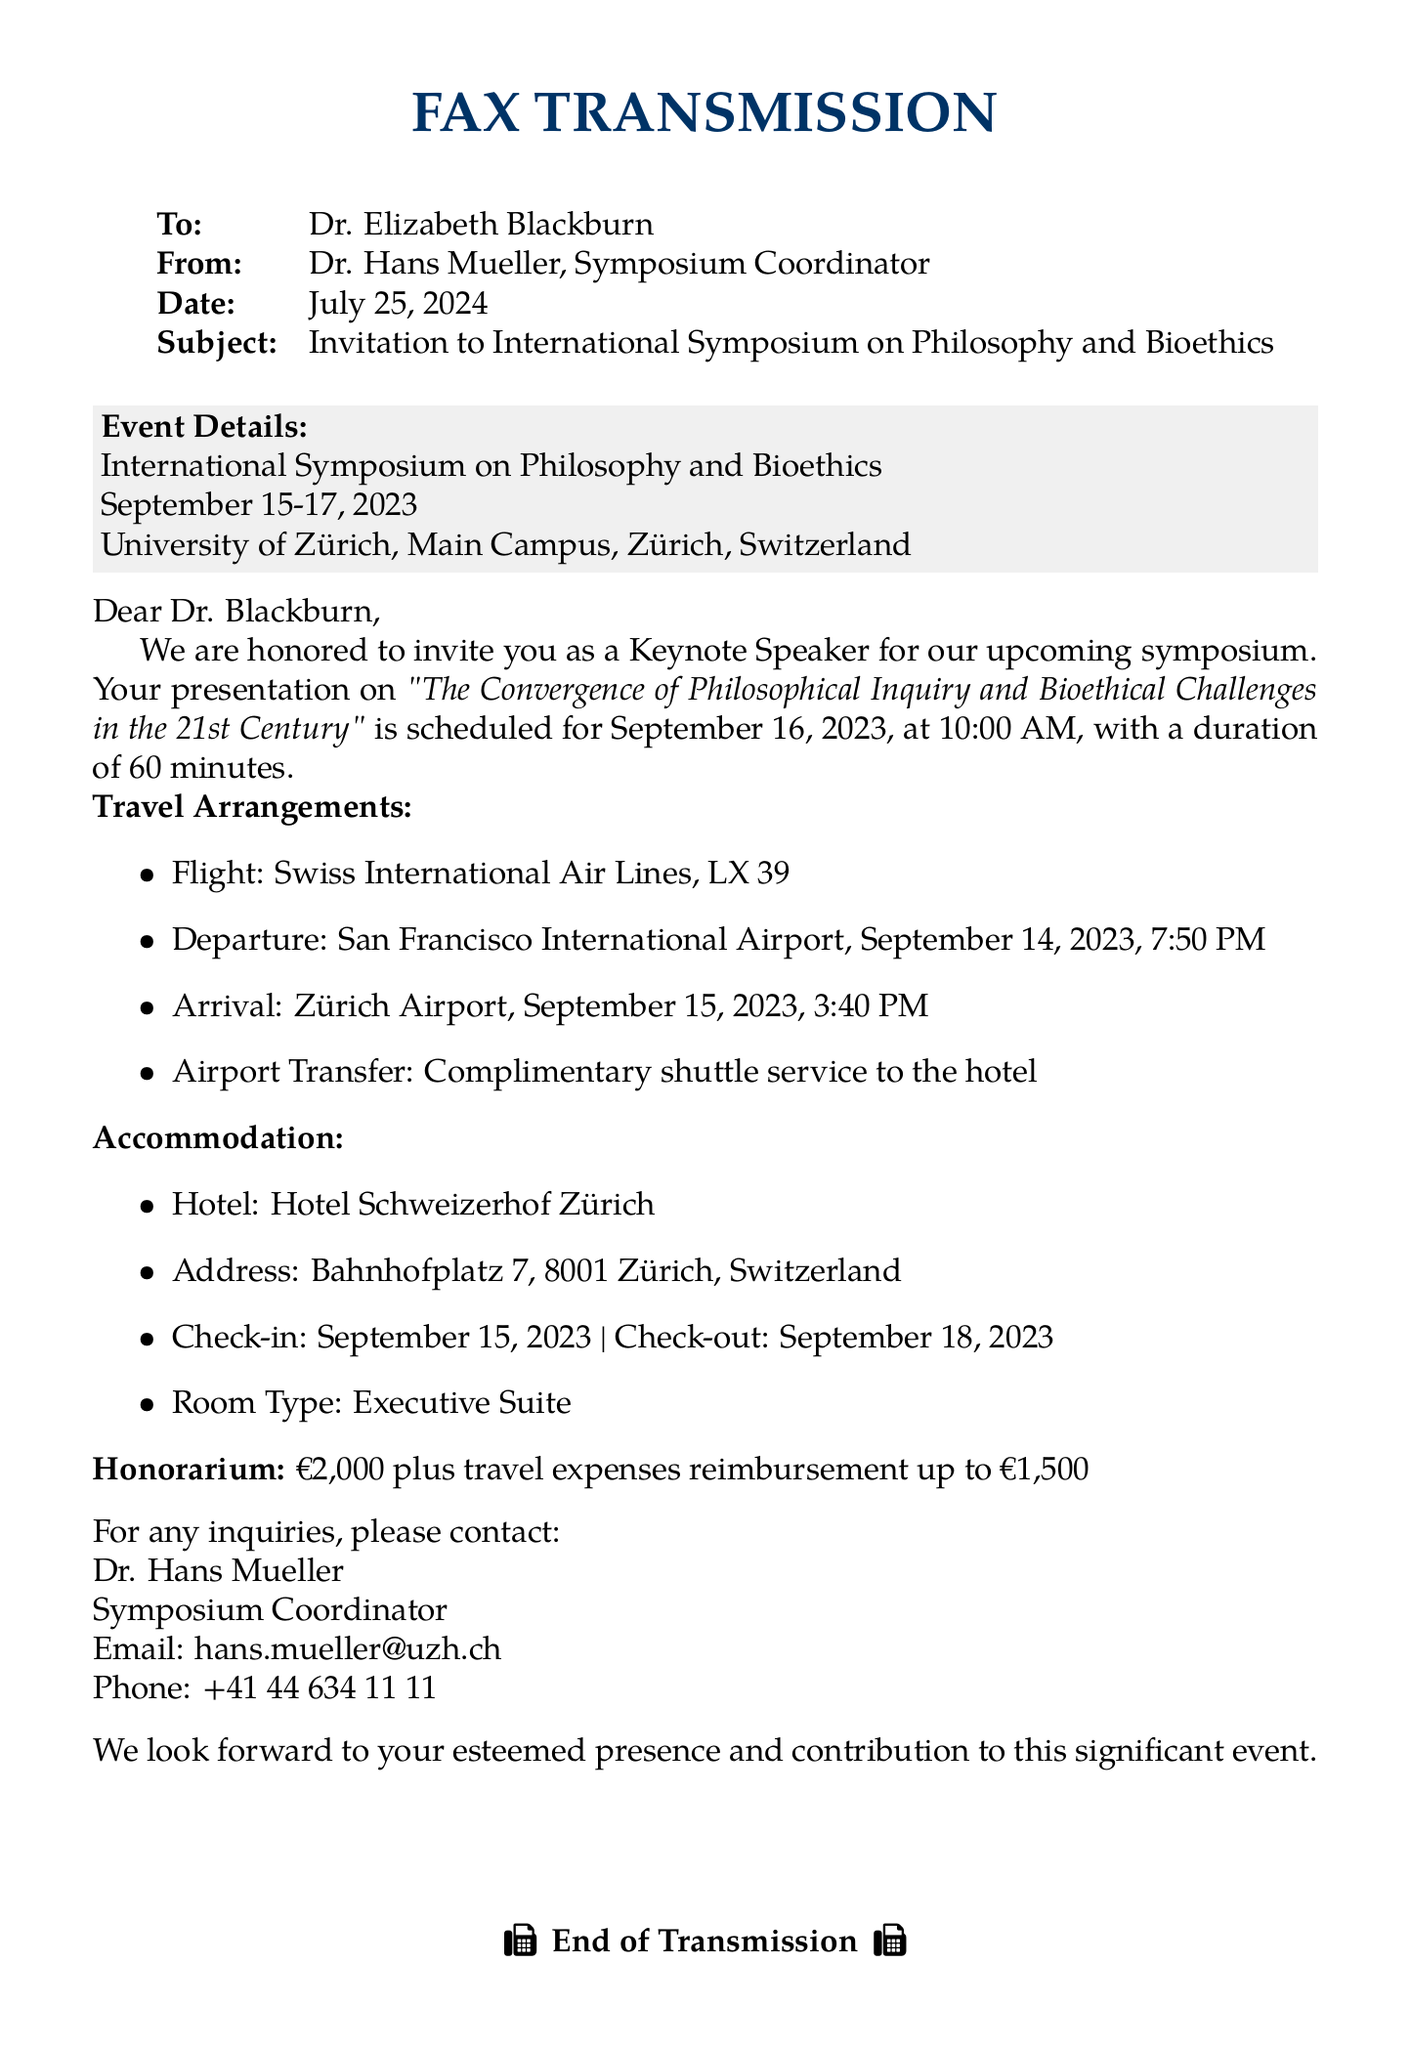What are the dates of the symposium? The symposium is scheduled for September 15-17, 2023, as mentioned in the event details.
Answer: September 15-17, 2023 Who is the keynote speaker? The document addresses Dr. Elizabeth Blackburn, indicating she is the intended keynote speaker.
Answer: Dr. Elizabeth Blackburn What is the honorarium amount? The document states the honorarium is €2,000.
Answer: €2,000 What is the check-in date for the hotel? The accommodation section specifies the check-in date as September 15, 2023.
Answer: September 15, 2023 What flight number is scheduled for the keynote speaker? The travel arrangements section lists flight LX 39 as the scheduled flight.
Answer: LX 39 Which hotel will accommodate the keynote speaker? The document specifies the Hotel Schweizerhof Zürich as the accommodation.
Answer: Hotel Schweizerhof Zürich At what time is the keynote presentation scheduled? The document details that the presentation is scheduled for 10:00 AM on September 16, 2023.
Answer: 10:00 AM What is the airport for the arrival? The travel arrangements section indicates Zürich Airport as the arrival airport.
Answer: Zürich Airport What is the maximum travel expenses reimbursement amount? The document mentions a reimbursement up to €1,500 for travel expenses.
Answer: €1,500 